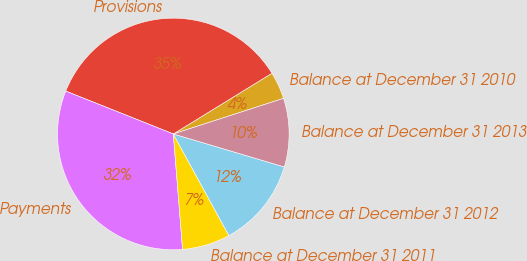<chart> <loc_0><loc_0><loc_500><loc_500><pie_chart><fcel>Balance at December 31 2010<fcel>Provisions<fcel>Payments<fcel>Balance at December 31 2011<fcel>Balance at December 31 2012<fcel>Balance at December 31 2013<nl><fcel>3.81%<fcel>35.19%<fcel>32.31%<fcel>6.69%<fcel>12.44%<fcel>9.57%<nl></chart> 